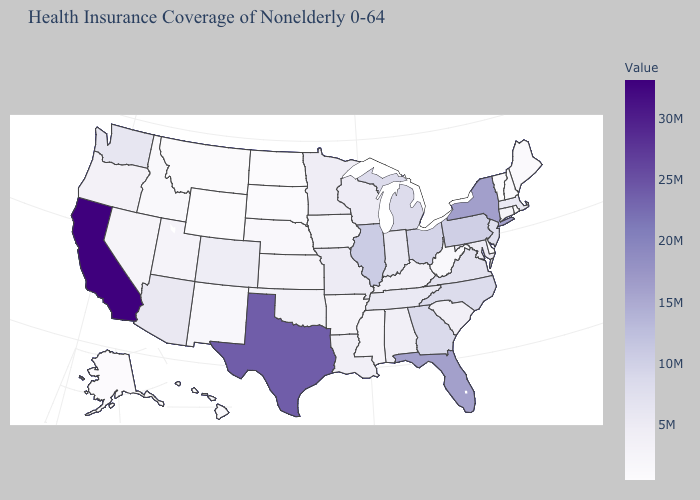Does the map have missing data?
Short answer required. No. Which states have the lowest value in the USA?
Write a very short answer. Wyoming. Which states have the lowest value in the MidWest?
Be succinct. North Dakota. Among the states that border Arizona , which have the lowest value?
Quick response, please. New Mexico. 